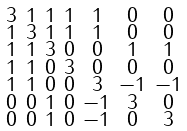<formula> <loc_0><loc_0><loc_500><loc_500>\begin{smallmatrix} 3 & 1 & 1 & 1 & 1 & 0 & 0 \\ 1 & 3 & 1 & 1 & 1 & 0 & 0 \\ 1 & 1 & 3 & 0 & 0 & 1 & 1 \\ 1 & 1 & 0 & 3 & 0 & 0 & 0 \\ 1 & 1 & 0 & 0 & 3 & - 1 & - 1 \\ 0 & 0 & 1 & 0 & - 1 & 3 & 0 \\ 0 & 0 & 1 & 0 & - 1 & 0 & 3 \end{smallmatrix}</formula> 